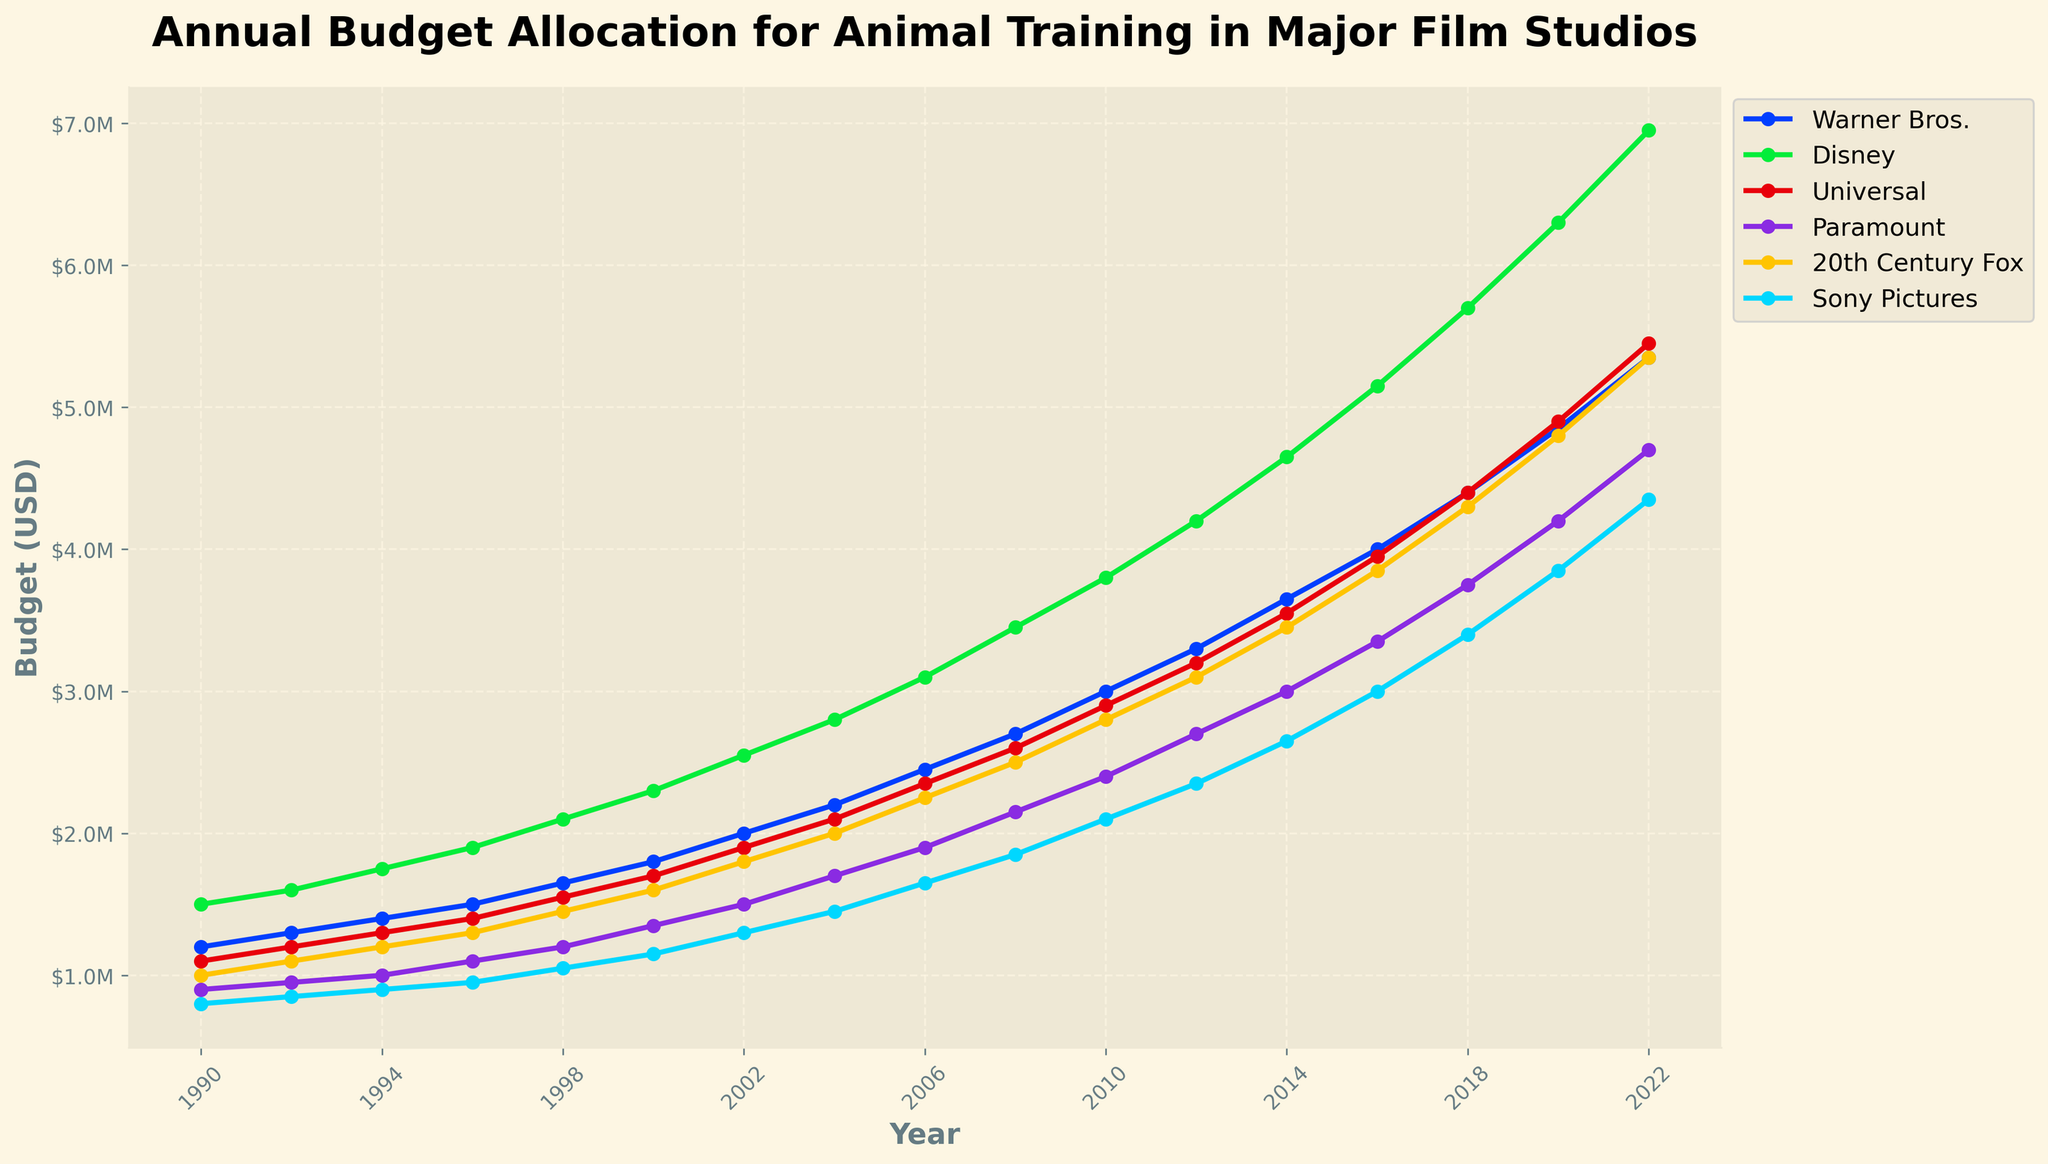What year did Disney allocate the most budget for animal training? To find the year Disney allocated the highest budget for animal training, we look at the line representing Disney on the graph and identify the peak value. The highest point for the Disney line occurs in 2022.
Answer: 2022 Which studio had the lowest budget allocation in 1990? To determine which studio had the lowest budget allocation in 1990, we compare all values on the graph for 1990. The value for Sony Pictures in 1990 is the lowest among all studios.
Answer: Sony Pictures What is the average budget allocation by Warner Bros. from 1990 to 2022? Calculate the average by summing Warner Bros.'s budget allocations from 1990 to 2022 and dividing by the number of years. Sum = 1.2M+1.3M+1.4M+1.5M+1.65M+1.8M+2.0M+2.2M+2.45M+2.7M+3.0M+3.3M+3.65M+4.0M+4.4M+4.85M+5.35M = 52.75M, number of years = 17. Average = 52.75M/17
Answer: $3.1M In which year did Universal's budget allocation surpass $5 million? Examine Universal's line on the graph and identify the first year the budget surpasses the $5M mark. This first occurs in 2022.
Answer: 2022 How much more was Disney's budget in 2022 compared to 2002? Subtract Disney's budget value in 2002 from its value in 2022. Disney's 2022 budget = 6.95M, 2002 budget = 2.55M. Difference = 6.95M - 2.55M = 4.4M.
Answer: $4.4M Which studio had a higher budget allocation in 2018, Warner Bros. or Paramount? Compare the budget values for both studios in 2018. Warner Bros. = 4.4M, Paramount = 3.75M. Warner Bros. has a higher allocation.
Answer: Warner Bros What is the total budget allocation across all studios in 1998? Sum each studio's budget value for 1998. Total = 1.65M + 2.1M + 1.55M + 1.2M + 1.45M + 1.05M = 8.0M.
Answer: $8.0M Between 2006 and 2010, which studio experienced the largest increase in budget allocation? Calculate the budget increase between 2006 and 2010 for each studio and find the maximum. Warner Bros.: 3.0M-2.45M=0.55M, Disney: 3.8M-3.1M=0.7M, Universal: 2.9M-2.35M=0.55M, Paramount: 2.4M-1.9M=0.5M, 20th C Fox: 2.8M-2.25M=0.55M, Sony Pictures: 2.1M-1.65M=0.45M. Largest increase is for Disney.
Answer: Disney How does the budget growth trend for Sony Pictures from 1990 to 2022 compare with Universal? Compare the slope of the budget lines for Sony Pictures and Universal from 1990 to 2022. Universal's budget starts at 1.1M and ends at 5.45M; Sony Pictures starts at 0.8M and ends at 4.35M. Universal's growth appears steeper and more consistent.
Answer: Universal What was the budget allocation for 20th Century Fox in 2000 and how does it compare to Sony Pictures in the same year? Find the values for both studios in 2000 and compare. 20th Century Fox: 1.6M, Sony Pictures: 1.15M. Fox's budget is higher.
Answer: 20th Century Fox 